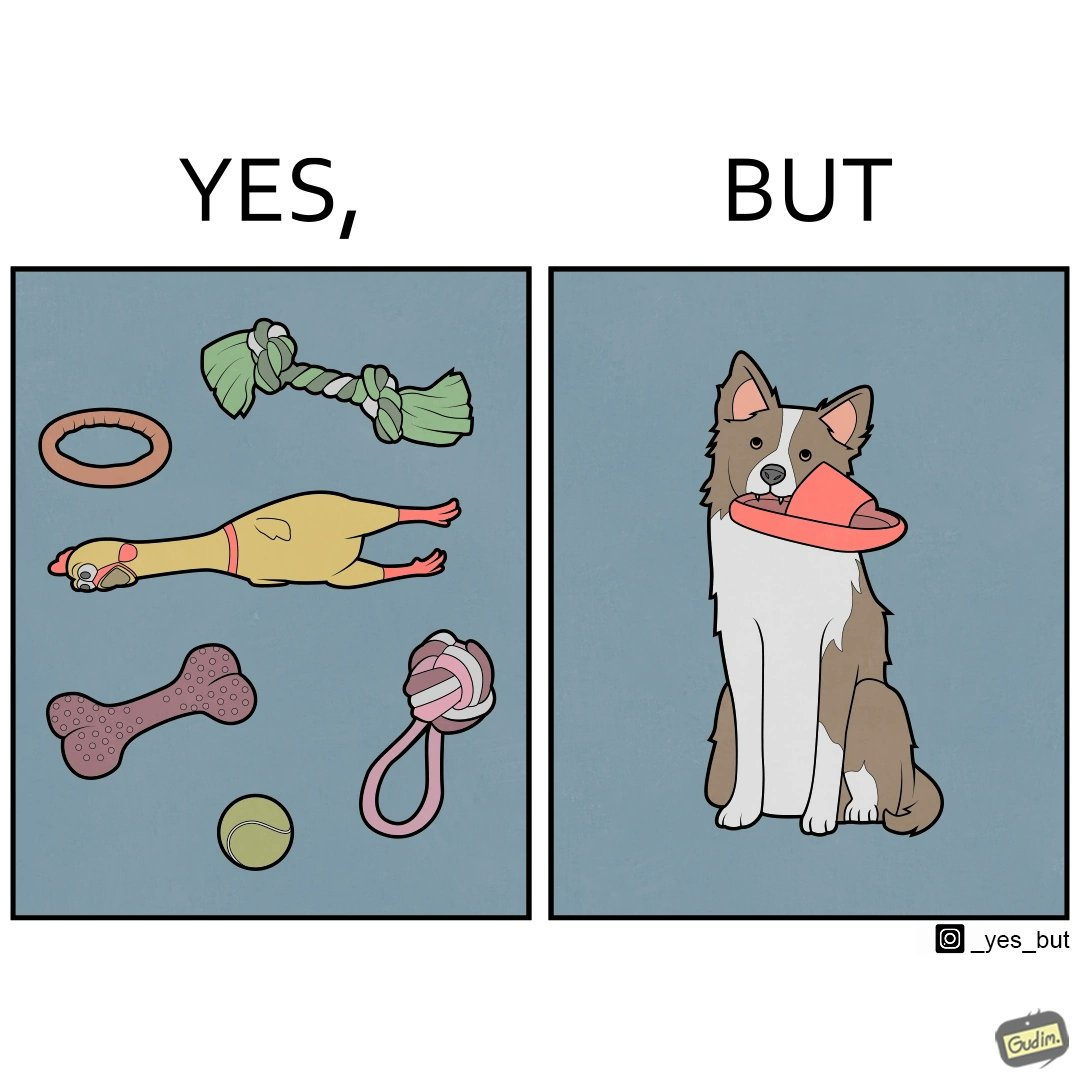Is there satirical content in this image? Yes, this image is satirical. 